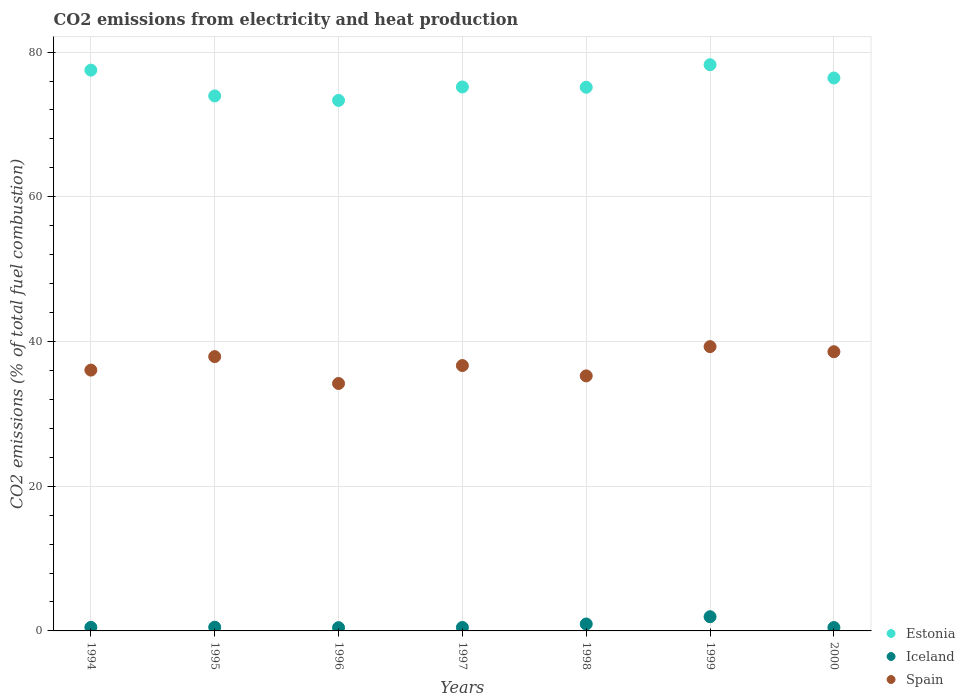Is the number of dotlines equal to the number of legend labels?
Your response must be concise. Yes. What is the amount of CO2 emitted in Iceland in 1998?
Offer a very short reply. 0.96. Across all years, what is the maximum amount of CO2 emitted in Spain?
Give a very brief answer. 39.29. Across all years, what is the minimum amount of CO2 emitted in Estonia?
Offer a very short reply. 73.32. In which year was the amount of CO2 emitted in Iceland maximum?
Provide a succinct answer. 1999. In which year was the amount of CO2 emitted in Estonia minimum?
Your answer should be compact. 1996. What is the total amount of CO2 emitted in Spain in the graph?
Offer a terse response. 257.96. What is the difference between the amount of CO2 emitted in Spain in 1998 and that in 1999?
Ensure brevity in your answer.  -4.05. What is the difference between the amount of CO2 emitted in Iceland in 1994 and the amount of CO2 emitted in Spain in 1999?
Your answer should be compact. -38.8. What is the average amount of CO2 emitted in Spain per year?
Provide a succinct answer. 36.85. In the year 1997, what is the difference between the amount of CO2 emitted in Estonia and amount of CO2 emitted in Iceland?
Keep it short and to the point. 74.7. What is the ratio of the amount of CO2 emitted in Spain in 1994 to that in 1997?
Your response must be concise. 0.98. Is the difference between the amount of CO2 emitted in Estonia in 1994 and 2000 greater than the difference between the amount of CO2 emitted in Iceland in 1994 and 2000?
Offer a very short reply. Yes. What is the difference between the highest and the second highest amount of CO2 emitted in Spain?
Offer a very short reply. 0.7. What is the difference between the highest and the lowest amount of CO2 emitted in Iceland?
Ensure brevity in your answer.  1.51. Is it the case that in every year, the sum of the amount of CO2 emitted in Spain and amount of CO2 emitted in Iceland  is greater than the amount of CO2 emitted in Estonia?
Your response must be concise. No. How many dotlines are there?
Provide a short and direct response. 3. What is the difference between two consecutive major ticks on the Y-axis?
Your answer should be compact. 20. Are the values on the major ticks of Y-axis written in scientific E-notation?
Provide a succinct answer. No. Does the graph contain any zero values?
Give a very brief answer. No. Does the graph contain grids?
Offer a very short reply. Yes. Where does the legend appear in the graph?
Make the answer very short. Bottom right. How many legend labels are there?
Your response must be concise. 3. How are the legend labels stacked?
Make the answer very short. Vertical. What is the title of the graph?
Give a very brief answer. CO2 emissions from electricity and heat production. Does "Timor-Leste" appear as one of the legend labels in the graph?
Offer a terse response. No. What is the label or title of the X-axis?
Give a very brief answer. Years. What is the label or title of the Y-axis?
Ensure brevity in your answer.  CO2 emissions (% of total fuel combustion). What is the CO2 emissions (% of total fuel combustion) in Estonia in 1994?
Your response must be concise. 77.51. What is the CO2 emissions (% of total fuel combustion) in Iceland in 1994?
Ensure brevity in your answer.  0.49. What is the CO2 emissions (% of total fuel combustion) of Spain in 1994?
Keep it short and to the point. 36.05. What is the CO2 emissions (% of total fuel combustion) in Estonia in 1995?
Offer a terse response. 73.94. What is the CO2 emissions (% of total fuel combustion) of Iceland in 1995?
Give a very brief answer. 0.51. What is the CO2 emissions (% of total fuel combustion) in Spain in 1995?
Your answer should be very brief. 37.91. What is the CO2 emissions (% of total fuel combustion) in Estonia in 1996?
Provide a succinct answer. 73.32. What is the CO2 emissions (% of total fuel combustion) of Iceland in 1996?
Make the answer very short. 0.45. What is the CO2 emissions (% of total fuel combustion) of Spain in 1996?
Your answer should be compact. 34.2. What is the CO2 emissions (% of total fuel combustion) in Estonia in 1997?
Your answer should be very brief. 75.18. What is the CO2 emissions (% of total fuel combustion) of Iceland in 1997?
Keep it short and to the point. 0.48. What is the CO2 emissions (% of total fuel combustion) of Spain in 1997?
Give a very brief answer. 36.68. What is the CO2 emissions (% of total fuel combustion) in Estonia in 1998?
Give a very brief answer. 75.14. What is the CO2 emissions (% of total fuel combustion) of Iceland in 1998?
Offer a very short reply. 0.96. What is the CO2 emissions (% of total fuel combustion) in Spain in 1998?
Offer a terse response. 35.25. What is the CO2 emissions (% of total fuel combustion) of Estonia in 1999?
Ensure brevity in your answer.  78.26. What is the CO2 emissions (% of total fuel combustion) in Iceland in 1999?
Your answer should be compact. 1.96. What is the CO2 emissions (% of total fuel combustion) in Spain in 1999?
Give a very brief answer. 39.29. What is the CO2 emissions (% of total fuel combustion) in Estonia in 2000?
Your answer should be very brief. 76.42. What is the CO2 emissions (% of total fuel combustion) in Iceland in 2000?
Ensure brevity in your answer.  0.47. What is the CO2 emissions (% of total fuel combustion) of Spain in 2000?
Offer a very short reply. 38.59. Across all years, what is the maximum CO2 emissions (% of total fuel combustion) in Estonia?
Your response must be concise. 78.26. Across all years, what is the maximum CO2 emissions (% of total fuel combustion) in Iceland?
Offer a terse response. 1.96. Across all years, what is the maximum CO2 emissions (% of total fuel combustion) in Spain?
Offer a very short reply. 39.29. Across all years, what is the minimum CO2 emissions (% of total fuel combustion) in Estonia?
Offer a terse response. 73.32. Across all years, what is the minimum CO2 emissions (% of total fuel combustion) of Iceland?
Offer a very short reply. 0.45. Across all years, what is the minimum CO2 emissions (% of total fuel combustion) in Spain?
Give a very brief answer. 34.2. What is the total CO2 emissions (% of total fuel combustion) in Estonia in the graph?
Your answer should be compact. 529.76. What is the total CO2 emissions (% of total fuel combustion) of Iceland in the graph?
Your response must be concise. 5.31. What is the total CO2 emissions (% of total fuel combustion) in Spain in the graph?
Your response must be concise. 257.96. What is the difference between the CO2 emissions (% of total fuel combustion) of Estonia in 1994 and that in 1995?
Provide a short and direct response. 3.57. What is the difference between the CO2 emissions (% of total fuel combustion) in Iceland in 1994 and that in 1995?
Provide a succinct answer. -0.02. What is the difference between the CO2 emissions (% of total fuel combustion) of Spain in 1994 and that in 1995?
Provide a short and direct response. -1.86. What is the difference between the CO2 emissions (% of total fuel combustion) of Estonia in 1994 and that in 1996?
Ensure brevity in your answer.  4.19. What is the difference between the CO2 emissions (% of total fuel combustion) in Iceland in 1994 and that in 1996?
Provide a short and direct response. 0.04. What is the difference between the CO2 emissions (% of total fuel combustion) of Spain in 1994 and that in 1996?
Your answer should be very brief. 1.85. What is the difference between the CO2 emissions (% of total fuel combustion) of Estonia in 1994 and that in 1997?
Your answer should be compact. 2.33. What is the difference between the CO2 emissions (% of total fuel combustion) in Iceland in 1994 and that in 1997?
Your response must be concise. 0.01. What is the difference between the CO2 emissions (% of total fuel combustion) of Spain in 1994 and that in 1997?
Your answer should be compact. -0.63. What is the difference between the CO2 emissions (% of total fuel combustion) in Estonia in 1994 and that in 1998?
Offer a very short reply. 2.37. What is the difference between the CO2 emissions (% of total fuel combustion) in Iceland in 1994 and that in 1998?
Make the answer very short. -0.47. What is the difference between the CO2 emissions (% of total fuel combustion) of Spain in 1994 and that in 1998?
Offer a very short reply. 0.8. What is the difference between the CO2 emissions (% of total fuel combustion) of Estonia in 1994 and that in 1999?
Keep it short and to the point. -0.75. What is the difference between the CO2 emissions (% of total fuel combustion) of Iceland in 1994 and that in 1999?
Offer a very short reply. -1.47. What is the difference between the CO2 emissions (% of total fuel combustion) in Spain in 1994 and that in 1999?
Give a very brief answer. -3.24. What is the difference between the CO2 emissions (% of total fuel combustion) of Estonia in 1994 and that in 2000?
Provide a short and direct response. 1.09. What is the difference between the CO2 emissions (% of total fuel combustion) in Iceland in 1994 and that in 2000?
Give a very brief answer. 0.03. What is the difference between the CO2 emissions (% of total fuel combustion) in Spain in 1994 and that in 2000?
Your answer should be very brief. -2.54. What is the difference between the CO2 emissions (% of total fuel combustion) of Estonia in 1995 and that in 1996?
Keep it short and to the point. 0.62. What is the difference between the CO2 emissions (% of total fuel combustion) in Iceland in 1995 and that in 1996?
Your answer should be compact. 0.06. What is the difference between the CO2 emissions (% of total fuel combustion) in Spain in 1995 and that in 1996?
Offer a terse response. 3.71. What is the difference between the CO2 emissions (% of total fuel combustion) of Estonia in 1995 and that in 1997?
Your response must be concise. -1.24. What is the difference between the CO2 emissions (% of total fuel combustion) of Iceland in 1995 and that in 1997?
Your answer should be compact. 0.04. What is the difference between the CO2 emissions (% of total fuel combustion) of Spain in 1995 and that in 1997?
Provide a short and direct response. 1.24. What is the difference between the CO2 emissions (% of total fuel combustion) in Estonia in 1995 and that in 1998?
Give a very brief answer. -1.2. What is the difference between the CO2 emissions (% of total fuel combustion) of Iceland in 1995 and that in 1998?
Ensure brevity in your answer.  -0.44. What is the difference between the CO2 emissions (% of total fuel combustion) in Spain in 1995 and that in 1998?
Your answer should be very brief. 2.67. What is the difference between the CO2 emissions (% of total fuel combustion) in Estonia in 1995 and that in 1999?
Your answer should be compact. -4.31. What is the difference between the CO2 emissions (% of total fuel combustion) of Iceland in 1995 and that in 1999?
Provide a short and direct response. -1.45. What is the difference between the CO2 emissions (% of total fuel combustion) in Spain in 1995 and that in 1999?
Your response must be concise. -1.38. What is the difference between the CO2 emissions (% of total fuel combustion) in Estonia in 1995 and that in 2000?
Provide a succinct answer. -2.48. What is the difference between the CO2 emissions (% of total fuel combustion) in Iceland in 1995 and that in 2000?
Your answer should be very brief. 0.05. What is the difference between the CO2 emissions (% of total fuel combustion) of Spain in 1995 and that in 2000?
Your answer should be compact. -0.68. What is the difference between the CO2 emissions (% of total fuel combustion) in Estonia in 1996 and that in 1997?
Your answer should be very brief. -1.86. What is the difference between the CO2 emissions (% of total fuel combustion) in Iceland in 1996 and that in 1997?
Provide a short and direct response. -0.02. What is the difference between the CO2 emissions (% of total fuel combustion) of Spain in 1996 and that in 1997?
Your response must be concise. -2.48. What is the difference between the CO2 emissions (% of total fuel combustion) of Estonia in 1996 and that in 1998?
Your response must be concise. -1.82. What is the difference between the CO2 emissions (% of total fuel combustion) of Iceland in 1996 and that in 1998?
Your answer should be compact. -0.5. What is the difference between the CO2 emissions (% of total fuel combustion) of Spain in 1996 and that in 1998?
Provide a short and direct response. -1.05. What is the difference between the CO2 emissions (% of total fuel combustion) in Estonia in 1996 and that in 1999?
Keep it short and to the point. -4.93. What is the difference between the CO2 emissions (% of total fuel combustion) in Iceland in 1996 and that in 1999?
Give a very brief answer. -1.51. What is the difference between the CO2 emissions (% of total fuel combustion) in Spain in 1996 and that in 1999?
Give a very brief answer. -5.09. What is the difference between the CO2 emissions (% of total fuel combustion) of Estonia in 1996 and that in 2000?
Keep it short and to the point. -3.1. What is the difference between the CO2 emissions (% of total fuel combustion) of Iceland in 1996 and that in 2000?
Offer a terse response. -0.01. What is the difference between the CO2 emissions (% of total fuel combustion) of Spain in 1996 and that in 2000?
Keep it short and to the point. -4.39. What is the difference between the CO2 emissions (% of total fuel combustion) of Estonia in 1997 and that in 1998?
Ensure brevity in your answer.  0.04. What is the difference between the CO2 emissions (% of total fuel combustion) of Iceland in 1997 and that in 1998?
Offer a terse response. -0.48. What is the difference between the CO2 emissions (% of total fuel combustion) of Spain in 1997 and that in 1998?
Your answer should be compact. 1.43. What is the difference between the CO2 emissions (% of total fuel combustion) in Estonia in 1997 and that in 1999?
Keep it short and to the point. -3.07. What is the difference between the CO2 emissions (% of total fuel combustion) in Iceland in 1997 and that in 1999?
Offer a terse response. -1.48. What is the difference between the CO2 emissions (% of total fuel combustion) in Spain in 1997 and that in 1999?
Make the answer very short. -2.62. What is the difference between the CO2 emissions (% of total fuel combustion) of Estonia in 1997 and that in 2000?
Your answer should be very brief. -1.24. What is the difference between the CO2 emissions (% of total fuel combustion) of Iceland in 1997 and that in 2000?
Offer a terse response. 0.01. What is the difference between the CO2 emissions (% of total fuel combustion) of Spain in 1997 and that in 2000?
Your response must be concise. -1.91. What is the difference between the CO2 emissions (% of total fuel combustion) in Estonia in 1998 and that in 1999?
Make the answer very short. -3.11. What is the difference between the CO2 emissions (% of total fuel combustion) of Iceland in 1998 and that in 1999?
Offer a very short reply. -1. What is the difference between the CO2 emissions (% of total fuel combustion) of Spain in 1998 and that in 1999?
Your answer should be very brief. -4.05. What is the difference between the CO2 emissions (% of total fuel combustion) in Estonia in 1998 and that in 2000?
Your response must be concise. -1.28. What is the difference between the CO2 emissions (% of total fuel combustion) of Iceland in 1998 and that in 2000?
Your response must be concise. 0.49. What is the difference between the CO2 emissions (% of total fuel combustion) of Spain in 1998 and that in 2000?
Offer a terse response. -3.34. What is the difference between the CO2 emissions (% of total fuel combustion) in Estonia in 1999 and that in 2000?
Keep it short and to the point. 1.84. What is the difference between the CO2 emissions (% of total fuel combustion) of Iceland in 1999 and that in 2000?
Ensure brevity in your answer.  1.5. What is the difference between the CO2 emissions (% of total fuel combustion) of Spain in 1999 and that in 2000?
Give a very brief answer. 0.7. What is the difference between the CO2 emissions (% of total fuel combustion) in Estonia in 1994 and the CO2 emissions (% of total fuel combustion) in Iceland in 1995?
Your response must be concise. 76.99. What is the difference between the CO2 emissions (% of total fuel combustion) of Estonia in 1994 and the CO2 emissions (% of total fuel combustion) of Spain in 1995?
Give a very brief answer. 39.59. What is the difference between the CO2 emissions (% of total fuel combustion) of Iceland in 1994 and the CO2 emissions (% of total fuel combustion) of Spain in 1995?
Offer a terse response. -37.42. What is the difference between the CO2 emissions (% of total fuel combustion) in Estonia in 1994 and the CO2 emissions (% of total fuel combustion) in Iceland in 1996?
Provide a succinct answer. 77.05. What is the difference between the CO2 emissions (% of total fuel combustion) of Estonia in 1994 and the CO2 emissions (% of total fuel combustion) of Spain in 1996?
Your answer should be compact. 43.31. What is the difference between the CO2 emissions (% of total fuel combustion) of Iceland in 1994 and the CO2 emissions (% of total fuel combustion) of Spain in 1996?
Your response must be concise. -33.71. What is the difference between the CO2 emissions (% of total fuel combustion) of Estonia in 1994 and the CO2 emissions (% of total fuel combustion) of Iceland in 1997?
Offer a very short reply. 77.03. What is the difference between the CO2 emissions (% of total fuel combustion) of Estonia in 1994 and the CO2 emissions (% of total fuel combustion) of Spain in 1997?
Offer a terse response. 40.83. What is the difference between the CO2 emissions (% of total fuel combustion) of Iceland in 1994 and the CO2 emissions (% of total fuel combustion) of Spain in 1997?
Keep it short and to the point. -36.19. What is the difference between the CO2 emissions (% of total fuel combustion) of Estonia in 1994 and the CO2 emissions (% of total fuel combustion) of Iceland in 1998?
Offer a terse response. 76.55. What is the difference between the CO2 emissions (% of total fuel combustion) in Estonia in 1994 and the CO2 emissions (% of total fuel combustion) in Spain in 1998?
Give a very brief answer. 42.26. What is the difference between the CO2 emissions (% of total fuel combustion) in Iceland in 1994 and the CO2 emissions (% of total fuel combustion) in Spain in 1998?
Your answer should be compact. -34.76. What is the difference between the CO2 emissions (% of total fuel combustion) in Estonia in 1994 and the CO2 emissions (% of total fuel combustion) in Iceland in 1999?
Provide a succinct answer. 75.55. What is the difference between the CO2 emissions (% of total fuel combustion) in Estonia in 1994 and the CO2 emissions (% of total fuel combustion) in Spain in 1999?
Provide a short and direct response. 38.21. What is the difference between the CO2 emissions (% of total fuel combustion) in Iceland in 1994 and the CO2 emissions (% of total fuel combustion) in Spain in 1999?
Provide a short and direct response. -38.8. What is the difference between the CO2 emissions (% of total fuel combustion) of Estonia in 1994 and the CO2 emissions (% of total fuel combustion) of Iceland in 2000?
Provide a succinct answer. 77.04. What is the difference between the CO2 emissions (% of total fuel combustion) of Estonia in 1994 and the CO2 emissions (% of total fuel combustion) of Spain in 2000?
Offer a very short reply. 38.92. What is the difference between the CO2 emissions (% of total fuel combustion) of Iceland in 1994 and the CO2 emissions (% of total fuel combustion) of Spain in 2000?
Offer a very short reply. -38.1. What is the difference between the CO2 emissions (% of total fuel combustion) of Estonia in 1995 and the CO2 emissions (% of total fuel combustion) of Iceland in 1996?
Give a very brief answer. 73.49. What is the difference between the CO2 emissions (% of total fuel combustion) of Estonia in 1995 and the CO2 emissions (% of total fuel combustion) of Spain in 1996?
Your answer should be very brief. 39.74. What is the difference between the CO2 emissions (% of total fuel combustion) of Iceland in 1995 and the CO2 emissions (% of total fuel combustion) of Spain in 1996?
Keep it short and to the point. -33.69. What is the difference between the CO2 emissions (% of total fuel combustion) of Estonia in 1995 and the CO2 emissions (% of total fuel combustion) of Iceland in 1997?
Your answer should be compact. 73.46. What is the difference between the CO2 emissions (% of total fuel combustion) in Estonia in 1995 and the CO2 emissions (% of total fuel combustion) in Spain in 1997?
Make the answer very short. 37.26. What is the difference between the CO2 emissions (% of total fuel combustion) of Iceland in 1995 and the CO2 emissions (% of total fuel combustion) of Spain in 1997?
Make the answer very short. -36.16. What is the difference between the CO2 emissions (% of total fuel combustion) in Estonia in 1995 and the CO2 emissions (% of total fuel combustion) in Iceland in 1998?
Provide a succinct answer. 72.98. What is the difference between the CO2 emissions (% of total fuel combustion) in Estonia in 1995 and the CO2 emissions (% of total fuel combustion) in Spain in 1998?
Give a very brief answer. 38.69. What is the difference between the CO2 emissions (% of total fuel combustion) in Iceland in 1995 and the CO2 emissions (% of total fuel combustion) in Spain in 1998?
Provide a succinct answer. -34.73. What is the difference between the CO2 emissions (% of total fuel combustion) in Estonia in 1995 and the CO2 emissions (% of total fuel combustion) in Iceland in 1999?
Ensure brevity in your answer.  71.98. What is the difference between the CO2 emissions (% of total fuel combustion) in Estonia in 1995 and the CO2 emissions (% of total fuel combustion) in Spain in 1999?
Give a very brief answer. 34.65. What is the difference between the CO2 emissions (% of total fuel combustion) in Iceland in 1995 and the CO2 emissions (% of total fuel combustion) in Spain in 1999?
Your response must be concise. -38.78. What is the difference between the CO2 emissions (% of total fuel combustion) in Estonia in 1995 and the CO2 emissions (% of total fuel combustion) in Iceland in 2000?
Your answer should be compact. 73.47. What is the difference between the CO2 emissions (% of total fuel combustion) in Estonia in 1995 and the CO2 emissions (% of total fuel combustion) in Spain in 2000?
Keep it short and to the point. 35.35. What is the difference between the CO2 emissions (% of total fuel combustion) of Iceland in 1995 and the CO2 emissions (% of total fuel combustion) of Spain in 2000?
Your response must be concise. -38.08. What is the difference between the CO2 emissions (% of total fuel combustion) in Estonia in 1996 and the CO2 emissions (% of total fuel combustion) in Iceland in 1997?
Make the answer very short. 72.85. What is the difference between the CO2 emissions (% of total fuel combustion) of Estonia in 1996 and the CO2 emissions (% of total fuel combustion) of Spain in 1997?
Ensure brevity in your answer.  36.65. What is the difference between the CO2 emissions (% of total fuel combustion) of Iceland in 1996 and the CO2 emissions (% of total fuel combustion) of Spain in 1997?
Keep it short and to the point. -36.22. What is the difference between the CO2 emissions (% of total fuel combustion) of Estonia in 1996 and the CO2 emissions (% of total fuel combustion) of Iceland in 1998?
Keep it short and to the point. 72.36. What is the difference between the CO2 emissions (% of total fuel combustion) in Estonia in 1996 and the CO2 emissions (% of total fuel combustion) in Spain in 1998?
Your response must be concise. 38.07. What is the difference between the CO2 emissions (% of total fuel combustion) of Iceland in 1996 and the CO2 emissions (% of total fuel combustion) of Spain in 1998?
Keep it short and to the point. -34.79. What is the difference between the CO2 emissions (% of total fuel combustion) in Estonia in 1996 and the CO2 emissions (% of total fuel combustion) in Iceland in 1999?
Make the answer very short. 71.36. What is the difference between the CO2 emissions (% of total fuel combustion) in Estonia in 1996 and the CO2 emissions (% of total fuel combustion) in Spain in 1999?
Offer a terse response. 34.03. What is the difference between the CO2 emissions (% of total fuel combustion) in Iceland in 1996 and the CO2 emissions (% of total fuel combustion) in Spain in 1999?
Ensure brevity in your answer.  -38.84. What is the difference between the CO2 emissions (% of total fuel combustion) in Estonia in 1996 and the CO2 emissions (% of total fuel combustion) in Iceland in 2000?
Make the answer very short. 72.86. What is the difference between the CO2 emissions (% of total fuel combustion) of Estonia in 1996 and the CO2 emissions (% of total fuel combustion) of Spain in 2000?
Provide a succinct answer. 34.73. What is the difference between the CO2 emissions (% of total fuel combustion) of Iceland in 1996 and the CO2 emissions (% of total fuel combustion) of Spain in 2000?
Provide a short and direct response. -38.14. What is the difference between the CO2 emissions (% of total fuel combustion) in Estonia in 1997 and the CO2 emissions (% of total fuel combustion) in Iceland in 1998?
Offer a terse response. 74.22. What is the difference between the CO2 emissions (% of total fuel combustion) in Estonia in 1997 and the CO2 emissions (% of total fuel combustion) in Spain in 1998?
Offer a terse response. 39.93. What is the difference between the CO2 emissions (% of total fuel combustion) of Iceland in 1997 and the CO2 emissions (% of total fuel combustion) of Spain in 1998?
Your answer should be very brief. -34.77. What is the difference between the CO2 emissions (% of total fuel combustion) in Estonia in 1997 and the CO2 emissions (% of total fuel combustion) in Iceland in 1999?
Offer a very short reply. 73.22. What is the difference between the CO2 emissions (% of total fuel combustion) in Estonia in 1997 and the CO2 emissions (% of total fuel combustion) in Spain in 1999?
Offer a very short reply. 35.89. What is the difference between the CO2 emissions (% of total fuel combustion) of Iceland in 1997 and the CO2 emissions (% of total fuel combustion) of Spain in 1999?
Your answer should be compact. -38.82. What is the difference between the CO2 emissions (% of total fuel combustion) in Estonia in 1997 and the CO2 emissions (% of total fuel combustion) in Iceland in 2000?
Provide a succinct answer. 74.72. What is the difference between the CO2 emissions (% of total fuel combustion) in Estonia in 1997 and the CO2 emissions (% of total fuel combustion) in Spain in 2000?
Your answer should be compact. 36.59. What is the difference between the CO2 emissions (% of total fuel combustion) in Iceland in 1997 and the CO2 emissions (% of total fuel combustion) in Spain in 2000?
Your answer should be compact. -38.11. What is the difference between the CO2 emissions (% of total fuel combustion) of Estonia in 1998 and the CO2 emissions (% of total fuel combustion) of Iceland in 1999?
Provide a succinct answer. 73.18. What is the difference between the CO2 emissions (% of total fuel combustion) in Estonia in 1998 and the CO2 emissions (% of total fuel combustion) in Spain in 1999?
Make the answer very short. 35.85. What is the difference between the CO2 emissions (% of total fuel combustion) in Iceland in 1998 and the CO2 emissions (% of total fuel combustion) in Spain in 1999?
Offer a very short reply. -38.34. What is the difference between the CO2 emissions (% of total fuel combustion) of Estonia in 1998 and the CO2 emissions (% of total fuel combustion) of Iceland in 2000?
Give a very brief answer. 74.68. What is the difference between the CO2 emissions (% of total fuel combustion) of Estonia in 1998 and the CO2 emissions (% of total fuel combustion) of Spain in 2000?
Ensure brevity in your answer.  36.55. What is the difference between the CO2 emissions (% of total fuel combustion) of Iceland in 1998 and the CO2 emissions (% of total fuel combustion) of Spain in 2000?
Your answer should be compact. -37.63. What is the difference between the CO2 emissions (% of total fuel combustion) in Estonia in 1999 and the CO2 emissions (% of total fuel combustion) in Iceland in 2000?
Offer a terse response. 77.79. What is the difference between the CO2 emissions (% of total fuel combustion) in Estonia in 1999 and the CO2 emissions (% of total fuel combustion) in Spain in 2000?
Make the answer very short. 39.67. What is the difference between the CO2 emissions (% of total fuel combustion) of Iceland in 1999 and the CO2 emissions (% of total fuel combustion) of Spain in 2000?
Provide a short and direct response. -36.63. What is the average CO2 emissions (% of total fuel combustion) in Estonia per year?
Give a very brief answer. 75.68. What is the average CO2 emissions (% of total fuel combustion) in Iceland per year?
Make the answer very short. 0.76. What is the average CO2 emissions (% of total fuel combustion) in Spain per year?
Provide a short and direct response. 36.85. In the year 1994, what is the difference between the CO2 emissions (% of total fuel combustion) of Estonia and CO2 emissions (% of total fuel combustion) of Iceland?
Keep it short and to the point. 77.02. In the year 1994, what is the difference between the CO2 emissions (% of total fuel combustion) of Estonia and CO2 emissions (% of total fuel combustion) of Spain?
Your answer should be compact. 41.46. In the year 1994, what is the difference between the CO2 emissions (% of total fuel combustion) of Iceland and CO2 emissions (% of total fuel combustion) of Spain?
Provide a short and direct response. -35.56. In the year 1995, what is the difference between the CO2 emissions (% of total fuel combustion) in Estonia and CO2 emissions (% of total fuel combustion) in Iceland?
Provide a short and direct response. 73.43. In the year 1995, what is the difference between the CO2 emissions (% of total fuel combustion) of Estonia and CO2 emissions (% of total fuel combustion) of Spain?
Provide a succinct answer. 36.03. In the year 1995, what is the difference between the CO2 emissions (% of total fuel combustion) of Iceland and CO2 emissions (% of total fuel combustion) of Spain?
Your response must be concise. -37.4. In the year 1996, what is the difference between the CO2 emissions (% of total fuel combustion) in Estonia and CO2 emissions (% of total fuel combustion) in Iceland?
Your answer should be compact. 72.87. In the year 1996, what is the difference between the CO2 emissions (% of total fuel combustion) in Estonia and CO2 emissions (% of total fuel combustion) in Spain?
Your answer should be very brief. 39.12. In the year 1996, what is the difference between the CO2 emissions (% of total fuel combustion) in Iceland and CO2 emissions (% of total fuel combustion) in Spain?
Offer a terse response. -33.75. In the year 1997, what is the difference between the CO2 emissions (% of total fuel combustion) of Estonia and CO2 emissions (% of total fuel combustion) of Iceland?
Give a very brief answer. 74.7. In the year 1997, what is the difference between the CO2 emissions (% of total fuel combustion) of Estonia and CO2 emissions (% of total fuel combustion) of Spain?
Provide a short and direct response. 38.5. In the year 1997, what is the difference between the CO2 emissions (% of total fuel combustion) in Iceland and CO2 emissions (% of total fuel combustion) in Spain?
Offer a very short reply. -36.2. In the year 1998, what is the difference between the CO2 emissions (% of total fuel combustion) in Estonia and CO2 emissions (% of total fuel combustion) in Iceland?
Provide a succinct answer. 74.18. In the year 1998, what is the difference between the CO2 emissions (% of total fuel combustion) in Estonia and CO2 emissions (% of total fuel combustion) in Spain?
Provide a succinct answer. 39.89. In the year 1998, what is the difference between the CO2 emissions (% of total fuel combustion) of Iceland and CO2 emissions (% of total fuel combustion) of Spain?
Keep it short and to the point. -34.29. In the year 1999, what is the difference between the CO2 emissions (% of total fuel combustion) of Estonia and CO2 emissions (% of total fuel combustion) of Iceland?
Your answer should be compact. 76.29. In the year 1999, what is the difference between the CO2 emissions (% of total fuel combustion) in Estonia and CO2 emissions (% of total fuel combustion) in Spain?
Give a very brief answer. 38.96. In the year 1999, what is the difference between the CO2 emissions (% of total fuel combustion) in Iceland and CO2 emissions (% of total fuel combustion) in Spain?
Keep it short and to the point. -37.33. In the year 2000, what is the difference between the CO2 emissions (% of total fuel combustion) in Estonia and CO2 emissions (% of total fuel combustion) in Iceland?
Ensure brevity in your answer.  75.95. In the year 2000, what is the difference between the CO2 emissions (% of total fuel combustion) of Estonia and CO2 emissions (% of total fuel combustion) of Spain?
Offer a terse response. 37.83. In the year 2000, what is the difference between the CO2 emissions (% of total fuel combustion) in Iceland and CO2 emissions (% of total fuel combustion) in Spain?
Make the answer very short. -38.12. What is the ratio of the CO2 emissions (% of total fuel combustion) in Estonia in 1994 to that in 1995?
Offer a terse response. 1.05. What is the ratio of the CO2 emissions (% of total fuel combustion) of Iceland in 1994 to that in 1995?
Your answer should be compact. 0.96. What is the ratio of the CO2 emissions (% of total fuel combustion) of Spain in 1994 to that in 1995?
Keep it short and to the point. 0.95. What is the ratio of the CO2 emissions (% of total fuel combustion) in Estonia in 1994 to that in 1996?
Offer a very short reply. 1.06. What is the ratio of the CO2 emissions (% of total fuel combustion) in Iceland in 1994 to that in 1996?
Provide a succinct answer. 1.08. What is the ratio of the CO2 emissions (% of total fuel combustion) in Spain in 1994 to that in 1996?
Offer a terse response. 1.05. What is the ratio of the CO2 emissions (% of total fuel combustion) of Estonia in 1994 to that in 1997?
Give a very brief answer. 1.03. What is the ratio of the CO2 emissions (% of total fuel combustion) in Iceland in 1994 to that in 1997?
Offer a terse response. 1.03. What is the ratio of the CO2 emissions (% of total fuel combustion) in Spain in 1994 to that in 1997?
Your answer should be very brief. 0.98. What is the ratio of the CO2 emissions (% of total fuel combustion) in Estonia in 1994 to that in 1998?
Give a very brief answer. 1.03. What is the ratio of the CO2 emissions (% of total fuel combustion) in Iceland in 1994 to that in 1998?
Give a very brief answer. 0.51. What is the ratio of the CO2 emissions (% of total fuel combustion) in Spain in 1994 to that in 1998?
Your response must be concise. 1.02. What is the ratio of the CO2 emissions (% of total fuel combustion) of Estonia in 1994 to that in 1999?
Your response must be concise. 0.99. What is the ratio of the CO2 emissions (% of total fuel combustion) in Spain in 1994 to that in 1999?
Keep it short and to the point. 0.92. What is the ratio of the CO2 emissions (% of total fuel combustion) in Estonia in 1994 to that in 2000?
Ensure brevity in your answer.  1.01. What is the ratio of the CO2 emissions (% of total fuel combustion) in Iceland in 1994 to that in 2000?
Offer a very short reply. 1.05. What is the ratio of the CO2 emissions (% of total fuel combustion) of Spain in 1994 to that in 2000?
Give a very brief answer. 0.93. What is the ratio of the CO2 emissions (% of total fuel combustion) of Estonia in 1995 to that in 1996?
Offer a terse response. 1.01. What is the ratio of the CO2 emissions (% of total fuel combustion) of Iceland in 1995 to that in 1996?
Ensure brevity in your answer.  1.13. What is the ratio of the CO2 emissions (% of total fuel combustion) in Spain in 1995 to that in 1996?
Give a very brief answer. 1.11. What is the ratio of the CO2 emissions (% of total fuel combustion) of Estonia in 1995 to that in 1997?
Make the answer very short. 0.98. What is the ratio of the CO2 emissions (% of total fuel combustion) in Spain in 1995 to that in 1997?
Your response must be concise. 1.03. What is the ratio of the CO2 emissions (% of total fuel combustion) in Estonia in 1995 to that in 1998?
Make the answer very short. 0.98. What is the ratio of the CO2 emissions (% of total fuel combustion) in Iceland in 1995 to that in 1998?
Offer a terse response. 0.54. What is the ratio of the CO2 emissions (% of total fuel combustion) in Spain in 1995 to that in 1998?
Provide a short and direct response. 1.08. What is the ratio of the CO2 emissions (% of total fuel combustion) in Estonia in 1995 to that in 1999?
Offer a terse response. 0.94. What is the ratio of the CO2 emissions (% of total fuel combustion) in Iceland in 1995 to that in 1999?
Provide a succinct answer. 0.26. What is the ratio of the CO2 emissions (% of total fuel combustion) in Spain in 1995 to that in 1999?
Give a very brief answer. 0.96. What is the ratio of the CO2 emissions (% of total fuel combustion) in Estonia in 1995 to that in 2000?
Offer a terse response. 0.97. What is the ratio of the CO2 emissions (% of total fuel combustion) in Iceland in 1995 to that in 2000?
Give a very brief answer. 1.1. What is the ratio of the CO2 emissions (% of total fuel combustion) in Spain in 1995 to that in 2000?
Provide a succinct answer. 0.98. What is the ratio of the CO2 emissions (% of total fuel combustion) of Estonia in 1996 to that in 1997?
Offer a very short reply. 0.98. What is the ratio of the CO2 emissions (% of total fuel combustion) of Iceland in 1996 to that in 1997?
Make the answer very short. 0.95. What is the ratio of the CO2 emissions (% of total fuel combustion) of Spain in 1996 to that in 1997?
Offer a terse response. 0.93. What is the ratio of the CO2 emissions (% of total fuel combustion) in Estonia in 1996 to that in 1998?
Your answer should be very brief. 0.98. What is the ratio of the CO2 emissions (% of total fuel combustion) of Iceland in 1996 to that in 1998?
Provide a succinct answer. 0.47. What is the ratio of the CO2 emissions (% of total fuel combustion) of Spain in 1996 to that in 1998?
Keep it short and to the point. 0.97. What is the ratio of the CO2 emissions (% of total fuel combustion) of Estonia in 1996 to that in 1999?
Give a very brief answer. 0.94. What is the ratio of the CO2 emissions (% of total fuel combustion) in Iceland in 1996 to that in 1999?
Offer a terse response. 0.23. What is the ratio of the CO2 emissions (% of total fuel combustion) of Spain in 1996 to that in 1999?
Offer a very short reply. 0.87. What is the ratio of the CO2 emissions (% of total fuel combustion) in Estonia in 1996 to that in 2000?
Offer a terse response. 0.96. What is the ratio of the CO2 emissions (% of total fuel combustion) in Iceland in 1996 to that in 2000?
Your answer should be compact. 0.97. What is the ratio of the CO2 emissions (% of total fuel combustion) in Spain in 1996 to that in 2000?
Your answer should be compact. 0.89. What is the ratio of the CO2 emissions (% of total fuel combustion) in Iceland in 1997 to that in 1998?
Provide a short and direct response. 0.5. What is the ratio of the CO2 emissions (% of total fuel combustion) in Spain in 1997 to that in 1998?
Offer a very short reply. 1.04. What is the ratio of the CO2 emissions (% of total fuel combustion) of Estonia in 1997 to that in 1999?
Provide a short and direct response. 0.96. What is the ratio of the CO2 emissions (% of total fuel combustion) in Iceland in 1997 to that in 1999?
Offer a terse response. 0.24. What is the ratio of the CO2 emissions (% of total fuel combustion) in Spain in 1997 to that in 1999?
Keep it short and to the point. 0.93. What is the ratio of the CO2 emissions (% of total fuel combustion) in Estonia in 1997 to that in 2000?
Your answer should be very brief. 0.98. What is the ratio of the CO2 emissions (% of total fuel combustion) in Iceland in 1997 to that in 2000?
Your answer should be compact. 1.02. What is the ratio of the CO2 emissions (% of total fuel combustion) in Spain in 1997 to that in 2000?
Offer a terse response. 0.95. What is the ratio of the CO2 emissions (% of total fuel combustion) in Estonia in 1998 to that in 1999?
Ensure brevity in your answer.  0.96. What is the ratio of the CO2 emissions (% of total fuel combustion) of Iceland in 1998 to that in 1999?
Ensure brevity in your answer.  0.49. What is the ratio of the CO2 emissions (% of total fuel combustion) in Spain in 1998 to that in 1999?
Your response must be concise. 0.9. What is the ratio of the CO2 emissions (% of total fuel combustion) of Estonia in 1998 to that in 2000?
Give a very brief answer. 0.98. What is the ratio of the CO2 emissions (% of total fuel combustion) in Iceland in 1998 to that in 2000?
Provide a succinct answer. 2.06. What is the ratio of the CO2 emissions (% of total fuel combustion) of Spain in 1998 to that in 2000?
Make the answer very short. 0.91. What is the ratio of the CO2 emissions (% of total fuel combustion) in Estonia in 1999 to that in 2000?
Offer a terse response. 1.02. What is the ratio of the CO2 emissions (% of total fuel combustion) in Iceland in 1999 to that in 2000?
Give a very brief answer. 4.22. What is the ratio of the CO2 emissions (% of total fuel combustion) of Spain in 1999 to that in 2000?
Offer a very short reply. 1.02. What is the difference between the highest and the second highest CO2 emissions (% of total fuel combustion) of Estonia?
Your answer should be very brief. 0.75. What is the difference between the highest and the second highest CO2 emissions (% of total fuel combustion) in Spain?
Keep it short and to the point. 0.7. What is the difference between the highest and the lowest CO2 emissions (% of total fuel combustion) in Estonia?
Provide a short and direct response. 4.93. What is the difference between the highest and the lowest CO2 emissions (% of total fuel combustion) in Iceland?
Give a very brief answer. 1.51. What is the difference between the highest and the lowest CO2 emissions (% of total fuel combustion) of Spain?
Your answer should be compact. 5.09. 